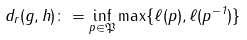<formula> <loc_0><loc_0><loc_500><loc_500>d _ { r } ( g , h ) \colon = \inf _ { p \in \mathfrak { P } } \max \{ \ell ( p ) , \ell ( p ^ { - 1 } ) \}</formula> 